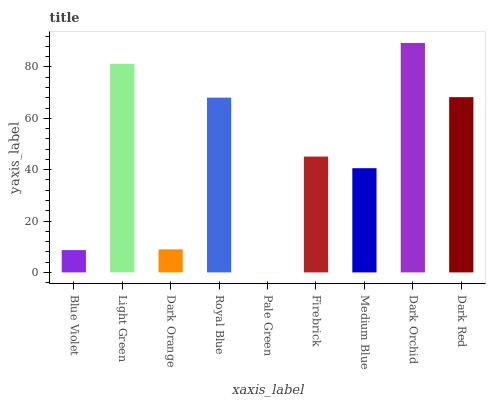Is Pale Green the minimum?
Answer yes or no. Yes. Is Dark Orchid the maximum?
Answer yes or no. Yes. Is Light Green the minimum?
Answer yes or no. No. Is Light Green the maximum?
Answer yes or no. No. Is Light Green greater than Blue Violet?
Answer yes or no. Yes. Is Blue Violet less than Light Green?
Answer yes or no. Yes. Is Blue Violet greater than Light Green?
Answer yes or no. No. Is Light Green less than Blue Violet?
Answer yes or no. No. Is Firebrick the high median?
Answer yes or no. Yes. Is Firebrick the low median?
Answer yes or no. Yes. Is Dark Red the high median?
Answer yes or no. No. Is Medium Blue the low median?
Answer yes or no. No. 